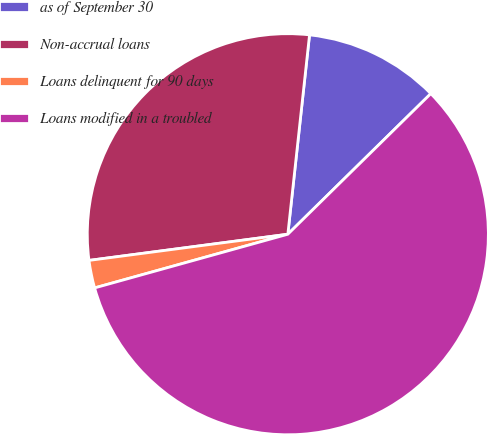<chart> <loc_0><loc_0><loc_500><loc_500><pie_chart><fcel>as of September 30<fcel>Non-accrual loans<fcel>Loans delinquent for 90 days<fcel>Loans modified in a troubled<nl><fcel>10.91%<fcel>28.81%<fcel>2.23%<fcel>58.05%<nl></chart> 